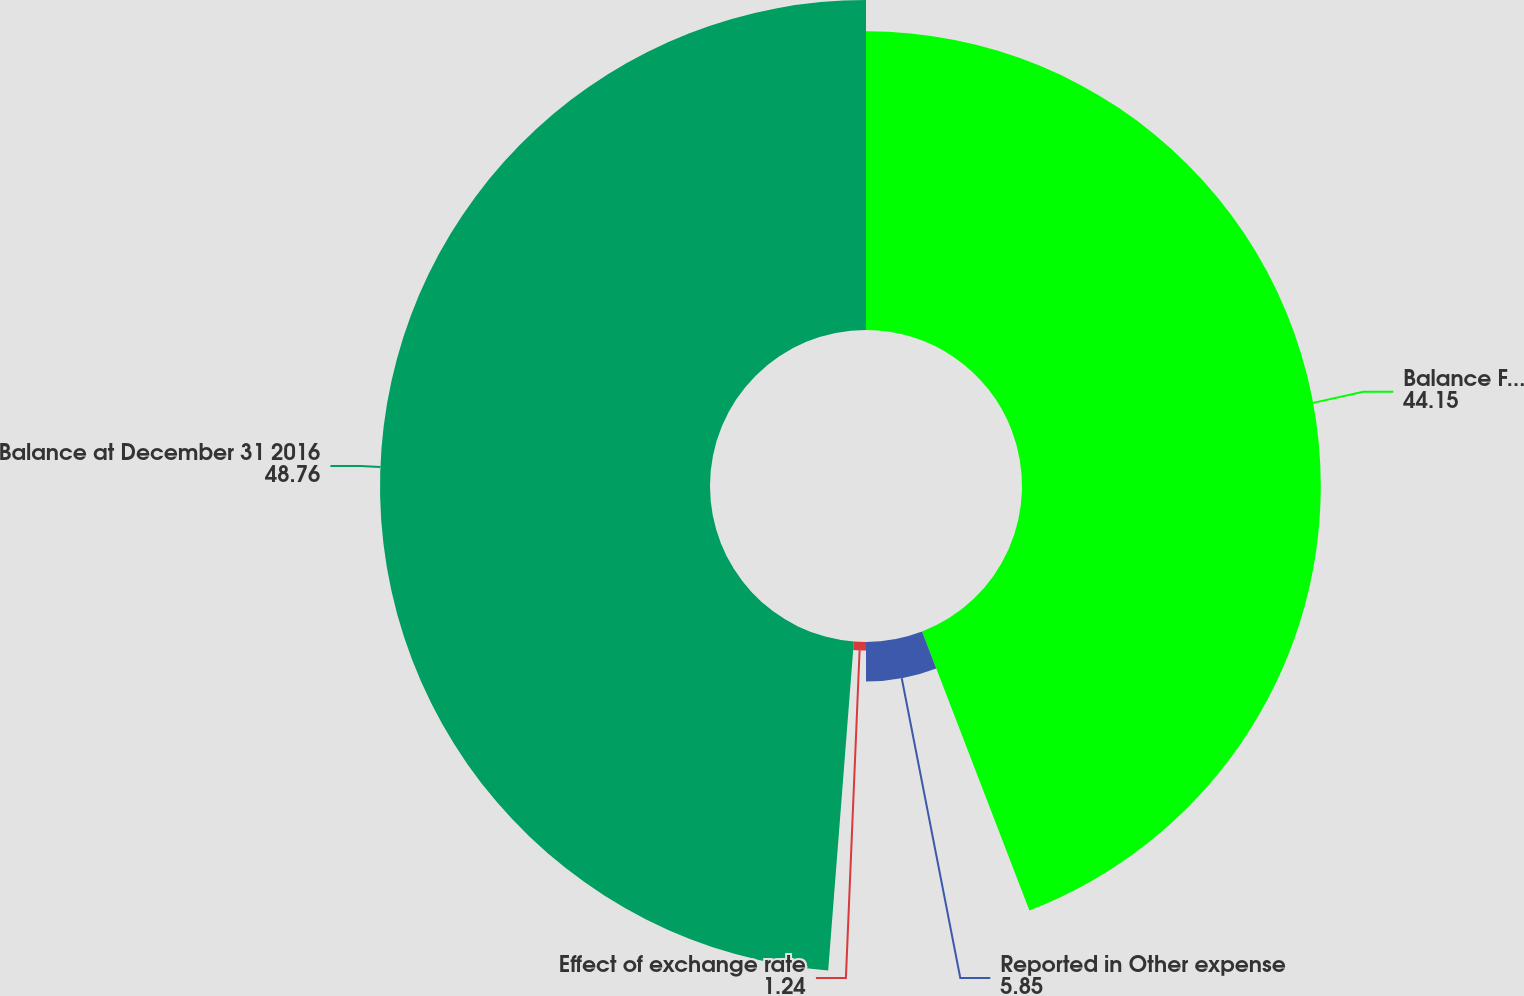<chart> <loc_0><loc_0><loc_500><loc_500><pie_chart><fcel>Balance February 29 2016<fcel>Reported in Other expense<fcel>Effect of exchange rate<fcel>Balance at December 31 2016<nl><fcel>44.15%<fcel>5.85%<fcel>1.24%<fcel>48.76%<nl></chart> 